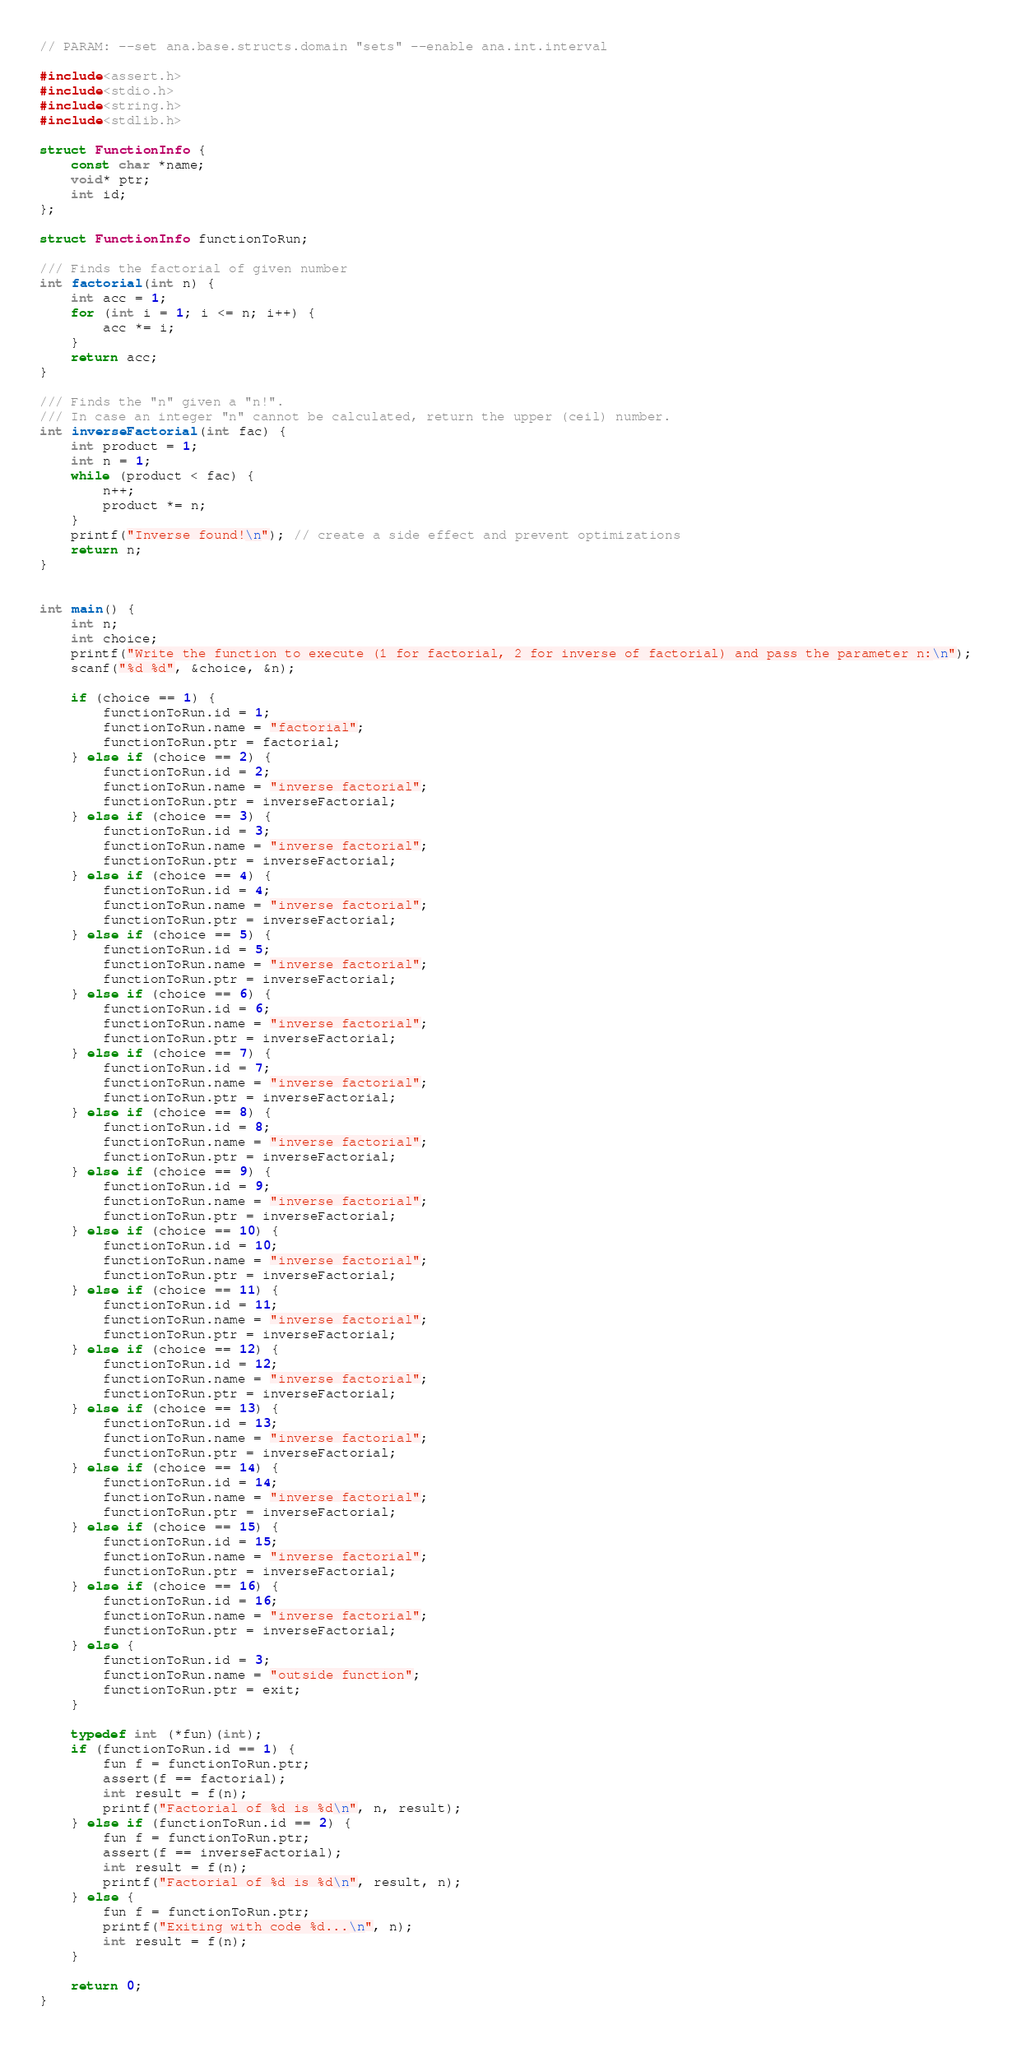Convert code to text. <code><loc_0><loc_0><loc_500><loc_500><_C_>// PARAM: --set ana.base.structs.domain "sets" --enable ana.int.interval

#include<assert.h>
#include<stdio.h>
#include<string.h>
#include<stdlib.h>

struct FunctionInfo {
    const char *name;
    void* ptr;
    int id;
};

struct FunctionInfo functionToRun;

/// Finds the factorial of given number
int factorial(int n) {
    int acc = 1;
    for (int i = 1; i <= n; i++) {
        acc *= i;
    }
    return acc;
}

/// Finds the "n" given a "n!".
/// In case an integer "n" cannot be calculated, return the upper (ceil) number.
int inverseFactorial(int fac) {
    int product = 1;
    int n = 1;
    while (product < fac) {
        n++;
        product *= n;
    }
    printf("Inverse found!\n"); // create a side effect and prevent optimizations
    return n;
}


int main() {
    int n;
    int choice;
    printf("Write the function to execute (1 for factorial, 2 for inverse of factorial) and pass the parameter n:\n");
    scanf("%d %d", &choice, &n);

    if (choice == 1) {
        functionToRun.id = 1;
        functionToRun.name = "factorial";
        functionToRun.ptr = factorial;
    } else if (choice == 2) {
        functionToRun.id = 2;
        functionToRun.name = "inverse factorial";
        functionToRun.ptr = inverseFactorial;
    } else if (choice == 3) {
        functionToRun.id = 3;
        functionToRun.name = "inverse factorial";
        functionToRun.ptr = inverseFactorial;
    } else if (choice == 4) {
        functionToRun.id = 4;
        functionToRun.name = "inverse factorial";
        functionToRun.ptr = inverseFactorial;
    } else if (choice == 5) {
        functionToRun.id = 5;
        functionToRun.name = "inverse factorial";
        functionToRun.ptr = inverseFactorial;
    } else if (choice == 6) {
        functionToRun.id = 6;
        functionToRun.name = "inverse factorial";
        functionToRun.ptr = inverseFactorial;
    } else if (choice == 7) {
        functionToRun.id = 7;
        functionToRun.name = "inverse factorial";
        functionToRun.ptr = inverseFactorial;
    } else if (choice == 8) {
        functionToRun.id = 8;
        functionToRun.name = "inverse factorial";
        functionToRun.ptr = inverseFactorial;
    } else if (choice == 9) {
        functionToRun.id = 9;
        functionToRun.name = "inverse factorial";
        functionToRun.ptr = inverseFactorial;
    } else if (choice == 10) {
        functionToRun.id = 10;
        functionToRun.name = "inverse factorial";
        functionToRun.ptr = inverseFactorial;
    } else if (choice == 11) {
        functionToRun.id = 11;
        functionToRun.name = "inverse factorial";
        functionToRun.ptr = inverseFactorial;
    } else if (choice == 12) {
        functionToRun.id = 12;
        functionToRun.name = "inverse factorial";
        functionToRun.ptr = inverseFactorial;
    } else if (choice == 13) {
        functionToRun.id = 13;
        functionToRun.name = "inverse factorial";
        functionToRun.ptr = inverseFactorial;
    } else if (choice == 14) {
        functionToRun.id = 14;
        functionToRun.name = "inverse factorial";
        functionToRun.ptr = inverseFactorial;
    } else if (choice == 15) {
        functionToRun.id = 15;
        functionToRun.name = "inverse factorial";
        functionToRun.ptr = inverseFactorial;
    } else if (choice == 16) {
        functionToRun.id = 16;
        functionToRun.name = "inverse factorial";
        functionToRun.ptr = inverseFactorial;
    } else {
        functionToRun.id = 3;
        functionToRun.name = "outside function";
        functionToRun.ptr = exit;
    }

    typedef int (*fun)(int);
    if (functionToRun.id == 1) {
        fun f = functionToRun.ptr;
        assert(f == factorial);
        int result = f(n);
        printf("Factorial of %d is %d\n", n, result);
    } else if (functionToRun.id == 2) {
        fun f = functionToRun.ptr;
        assert(f == inverseFactorial);
        int result = f(n);
        printf("Factorial of %d is %d\n", result, n);
    } else {
        fun f = functionToRun.ptr;
        printf("Exiting with code %d...\n", n);
        int result = f(n);
    }

    return 0;
}
</code> 